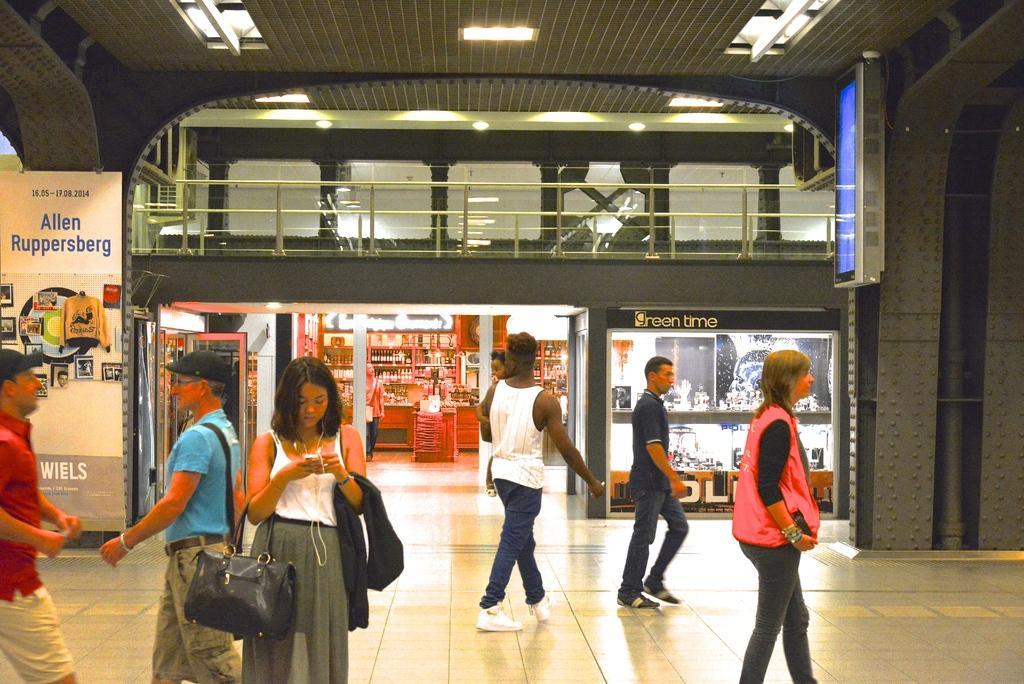How would you summarize this image in a sentence or two? There are so many people standing and walking in a mall. 